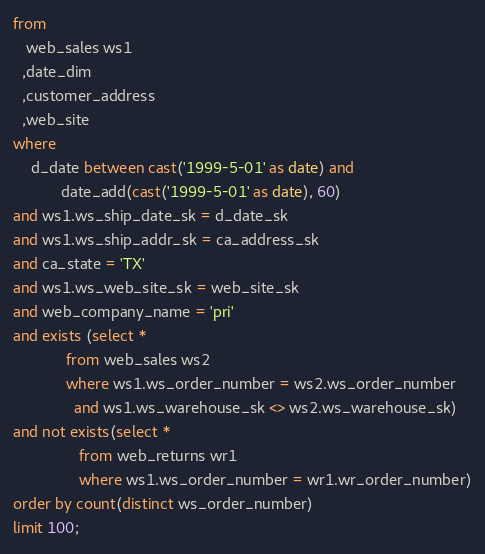Convert code to text. <code><loc_0><loc_0><loc_500><loc_500><_SQL_>from
   web_sales ws1
  ,date_dim
  ,customer_address
  ,web_site
where
    d_date between cast('1999-5-01' as date) and 
           date_add(cast('1999-5-01' as date), 60)
and ws1.ws_ship_date_sk = d_date_sk
and ws1.ws_ship_addr_sk = ca_address_sk
and ca_state = 'TX'
and ws1.ws_web_site_sk = web_site_sk
and web_company_name = 'pri'
and exists (select *
            from web_sales ws2
            where ws1.ws_order_number = ws2.ws_order_number
              and ws1.ws_warehouse_sk <> ws2.ws_warehouse_sk)
and not exists(select *
               from web_returns wr1
               where ws1.ws_order_number = wr1.wr_order_number)
order by count(distinct ws_order_number)
limit 100;
</code> 